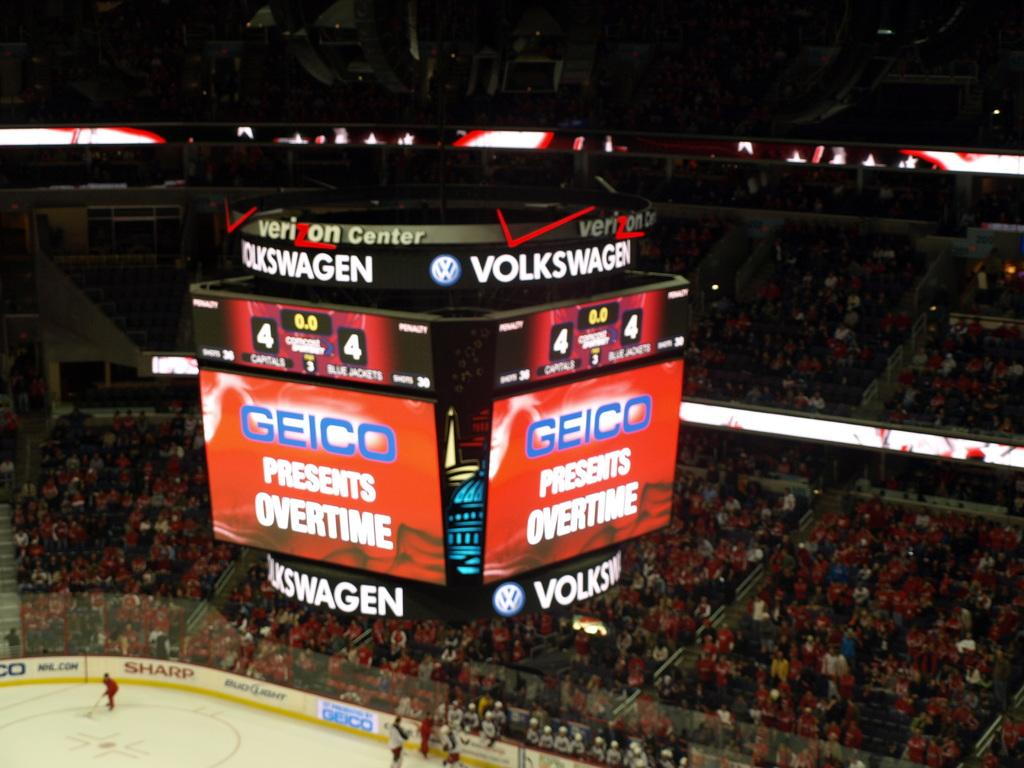<image>
Create a compact narrative representing the image presented. the overhead screen of a hockey rink, with geico presents overtime on display 